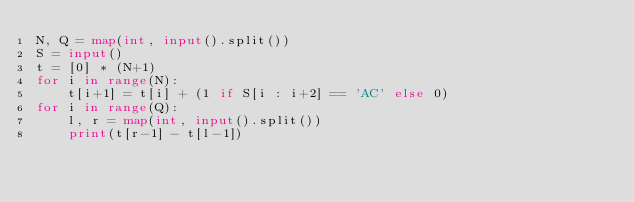<code> <loc_0><loc_0><loc_500><loc_500><_Python_>N, Q = map(int, input().split())
S = input()
t = [0] * (N+1)
for i in range(N):
    t[i+1] = t[i] + (1 if S[i : i+2] == 'AC' else 0)  
for i in range(Q):
    l, r = map(int, input().split())
    print(t[r-1] - t[l-1])

</code> 